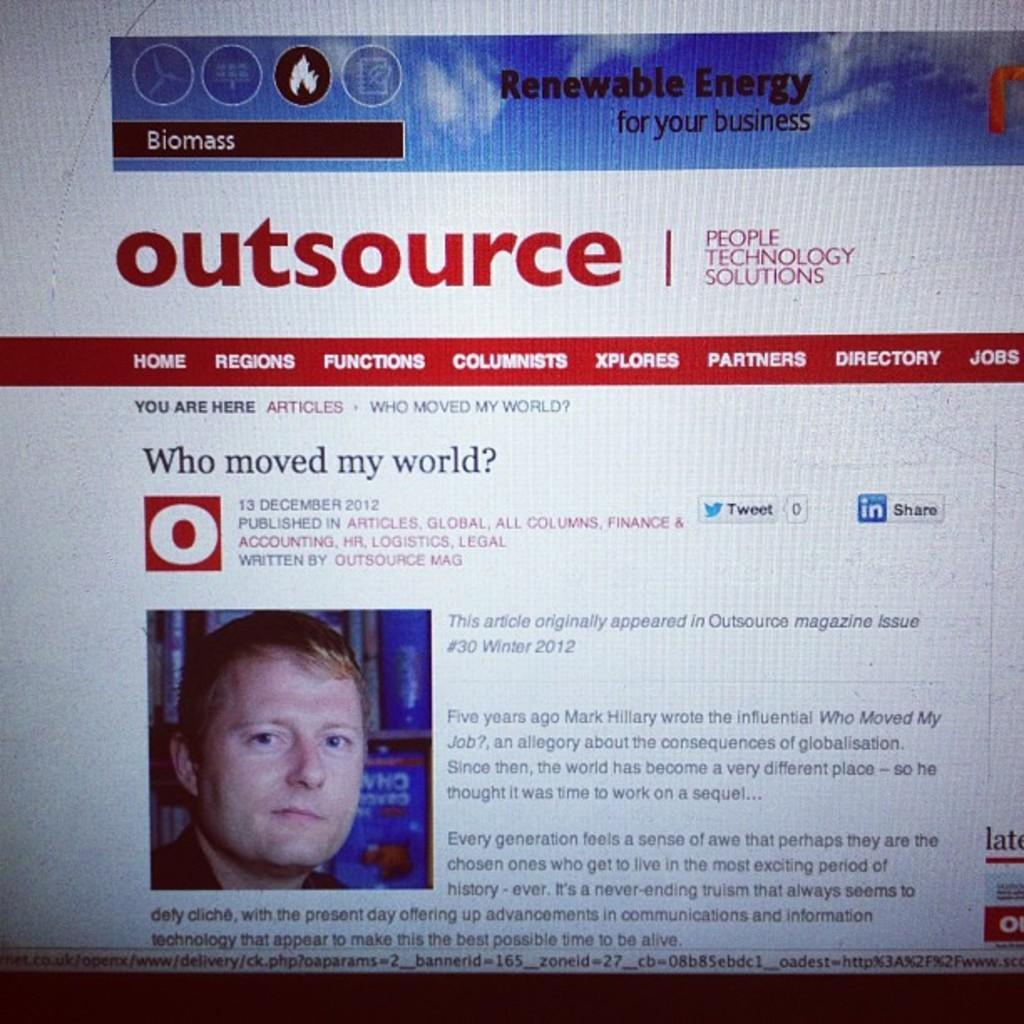How would you summarize this image in a sentence or two? In the picture there is a screen, on the screen there is some text present, there is a photograph of a person present on the screen. 